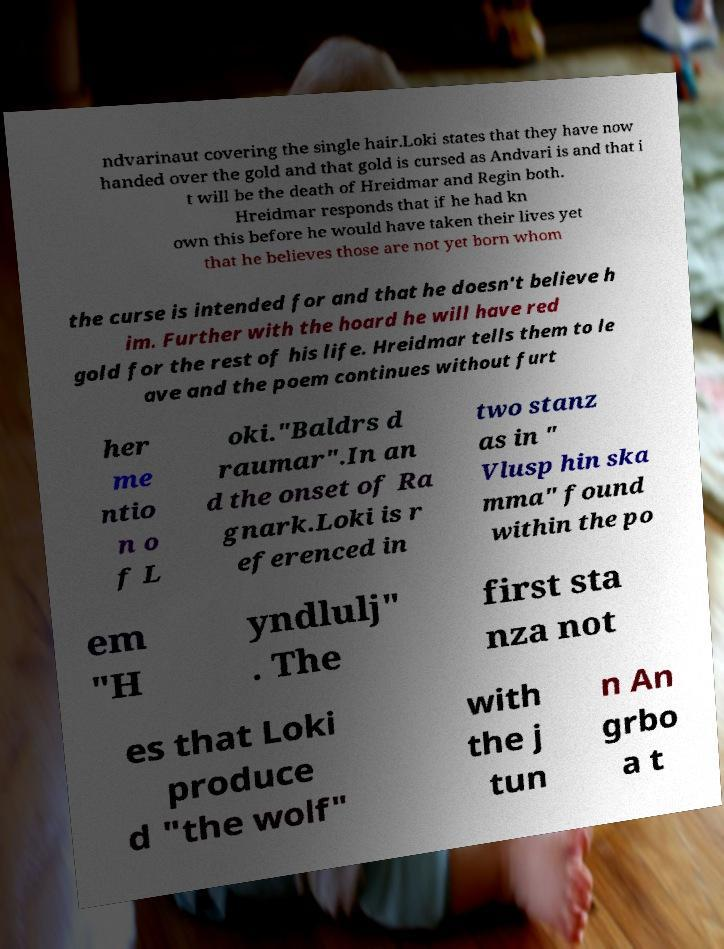Please read and relay the text visible in this image. What does it say? ndvarinaut covering the single hair.Loki states that they have now handed over the gold and that gold is cursed as Andvari is and that i t will be the death of Hreidmar and Regin both. Hreidmar responds that if he had kn own this before he would have taken their lives yet that he believes those are not yet born whom the curse is intended for and that he doesn't believe h im. Further with the hoard he will have red gold for the rest of his life. Hreidmar tells them to le ave and the poem continues without furt her me ntio n o f L oki."Baldrs d raumar".In an d the onset of Ra gnark.Loki is r eferenced in two stanz as in " Vlusp hin ska mma" found within the po em "H yndlulj" . The first sta nza not es that Loki produce d "the wolf" with the j tun n An grbo a t 